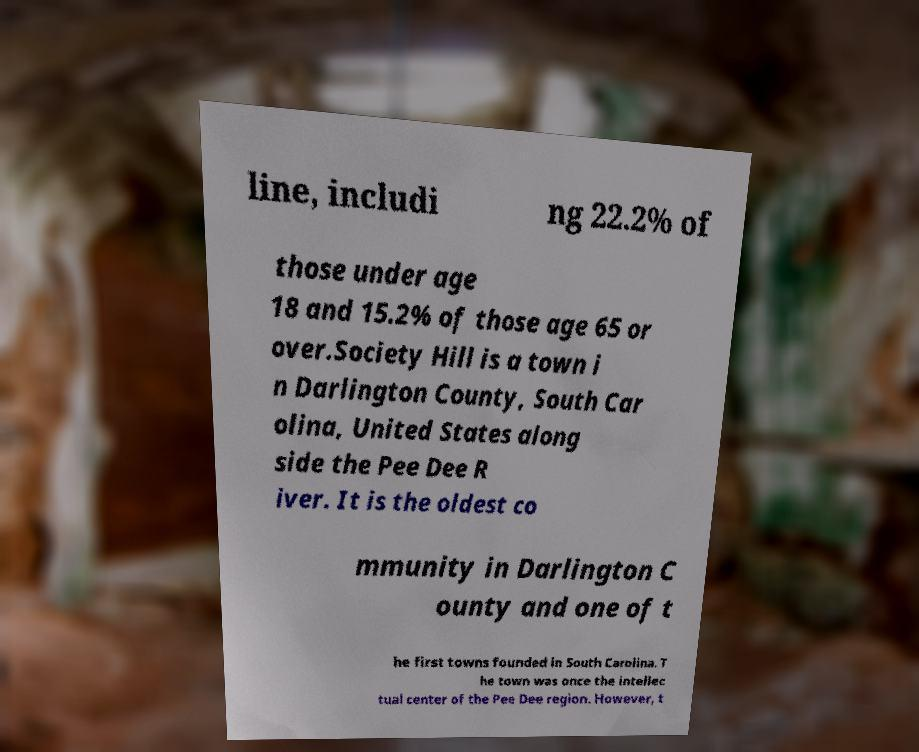Can you read and provide the text displayed in the image?This photo seems to have some interesting text. Can you extract and type it out for me? line, includi ng 22.2% of those under age 18 and 15.2% of those age 65 or over.Society Hill is a town i n Darlington County, South Car olina, United States along side the Pee Dee R iver. It is the oldest co mmunity in Darlington C ounty and one of t he first towns founded in South Carolina. T he town was once the intellec tual center of the Pee Dee region. However, t 